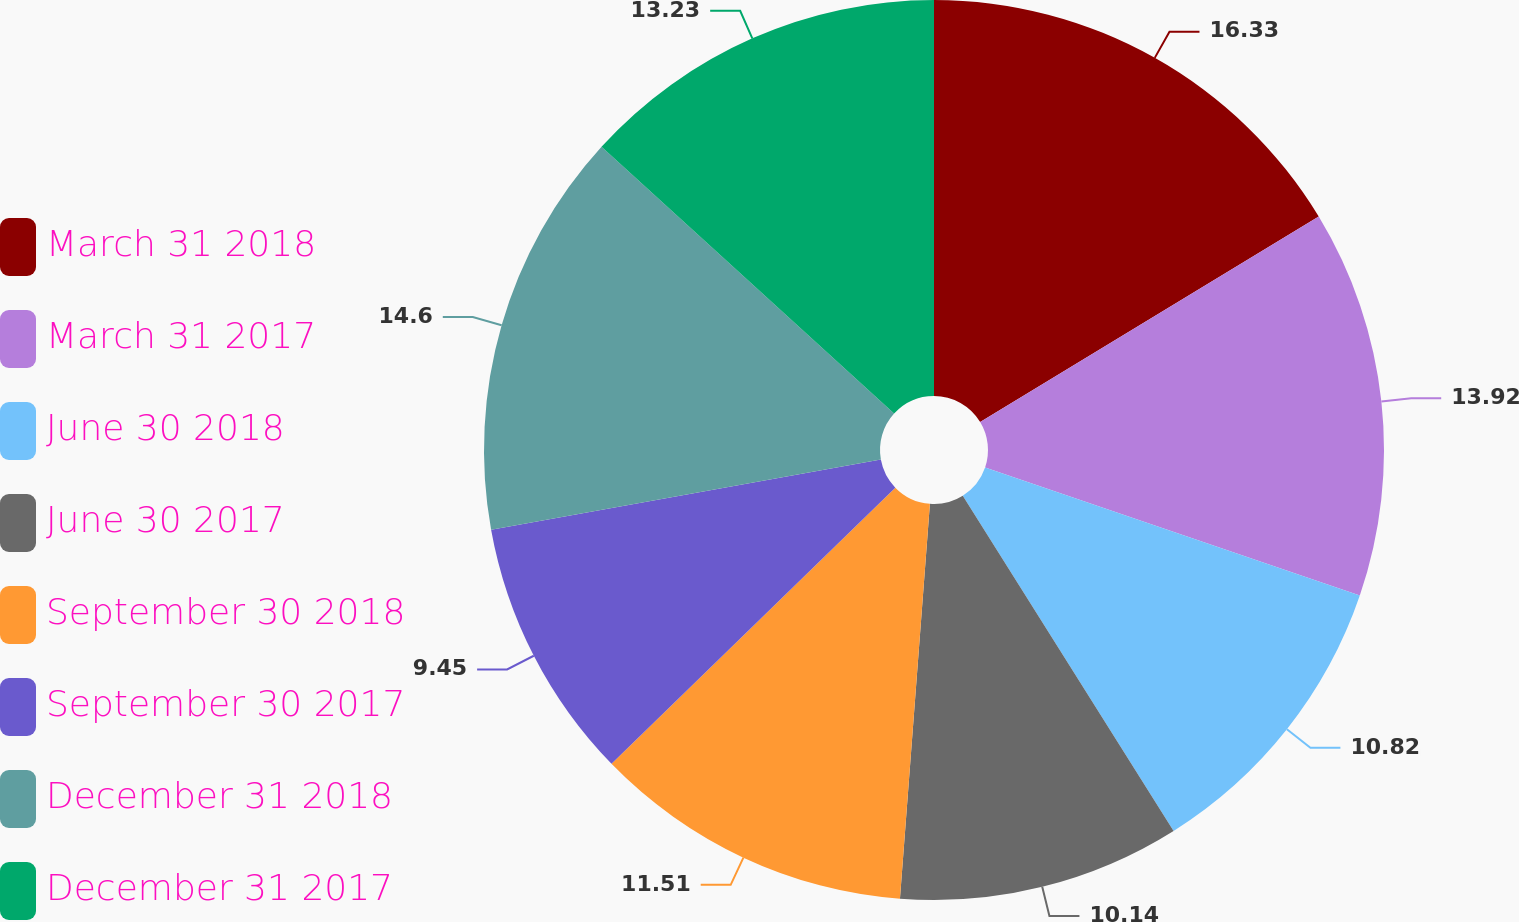Convert chart. <chart><loc_0><loc_0><loc_500><loc_500><pie_chart><fcel>March 31 2018<fcel>March 31 2017<fcel>June 30 2018<fcel>June 30 2017<fcel>September 30 2018<fcel>September 30 2017<fcel>December 31 2018<fcel>December 31 2017<nl><fcel>16.32%<fcel>13.92%<fcel>10.82%<fcel>10.14%<fcel>11.51%<fcel>9.45%<fcel>14.6%<fcel>13.23%<nl></chart> 